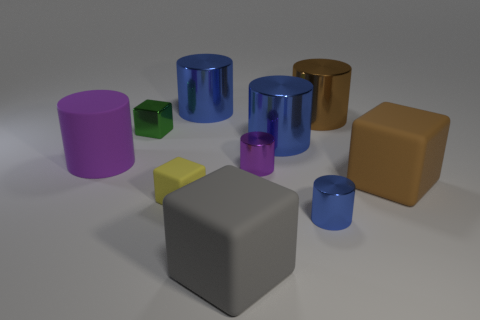How big is the brown object that is behind the block behind the brown cube?
Keep it short and to the point. Large. What material is the large thing that is both in front of the large purple rubber cylinder and behind the big gray thing?
Make the answer very short. Rubber. How many other objects are there of the same size as the yellow cube?
Keep it short and to the point. 3. The tiny metallic block has what color?
Your response must be concise. Green. Do the cube that is in front of the tiny blue shiny cylinder and the big cylinder to the right of the small blue shiny cylinder have the same color?
Offer a terse response. No. The green metal object has what size?
Make the answer very short. Small. There is a blue shiny object that is in front of the large purple thing; what is its size?
Ensure brevity in your answer.  Small. There is a big object that is both in front of the tiny green metal thing and behind the large purple thing; what is its shape?
Your answer should be compact. Cylinder. What number of other things are the same shape as the large brown rubber thing?
Keep it short and to the point. 3. What color is the other block that is the same size as the gray block?
Ensure brevity in your answer.  Brown. 